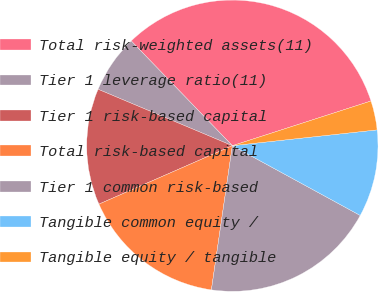<chart> <loc_0><loc_0><loc_500><loc_500><pie_chart><fcel>Total risk-weighted assets(11)<fcel>Tier 1 leverage ratio(11)<fcel>Tier 1 risk-based capital<fcel>Total risk-based capital<fcel>Tier 1 common risk-based<fcel>Tangible common equity /<fcel>Tangible equity / tangible<nl><fcel>32.25%<fcel>6.45%<fcel>12.9%<fcel>16.13%<fcel>19.35%<fcel>9.68%<fcel>3.23%<nl></chart> 